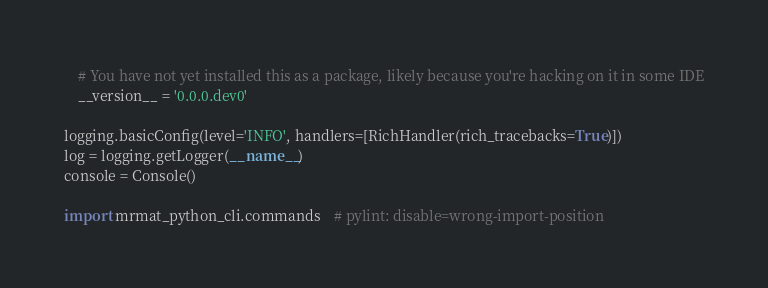<code> <loc_0><loc_0><loc_500><loc_500><_Python_>    # You have not yet installed this as a package, likely because you're hacking on it in some IDE
    __version__ = '0.0.0.dev0'

logging.basicConfig(level='INFO', handlers=[RichHandler(rich_tracebacks=True)])
log = logging.getLogger(__name__)
console = Console()

import mrmat_python_cli.commands    # pylint: disable=wrong-import-position
</code> 